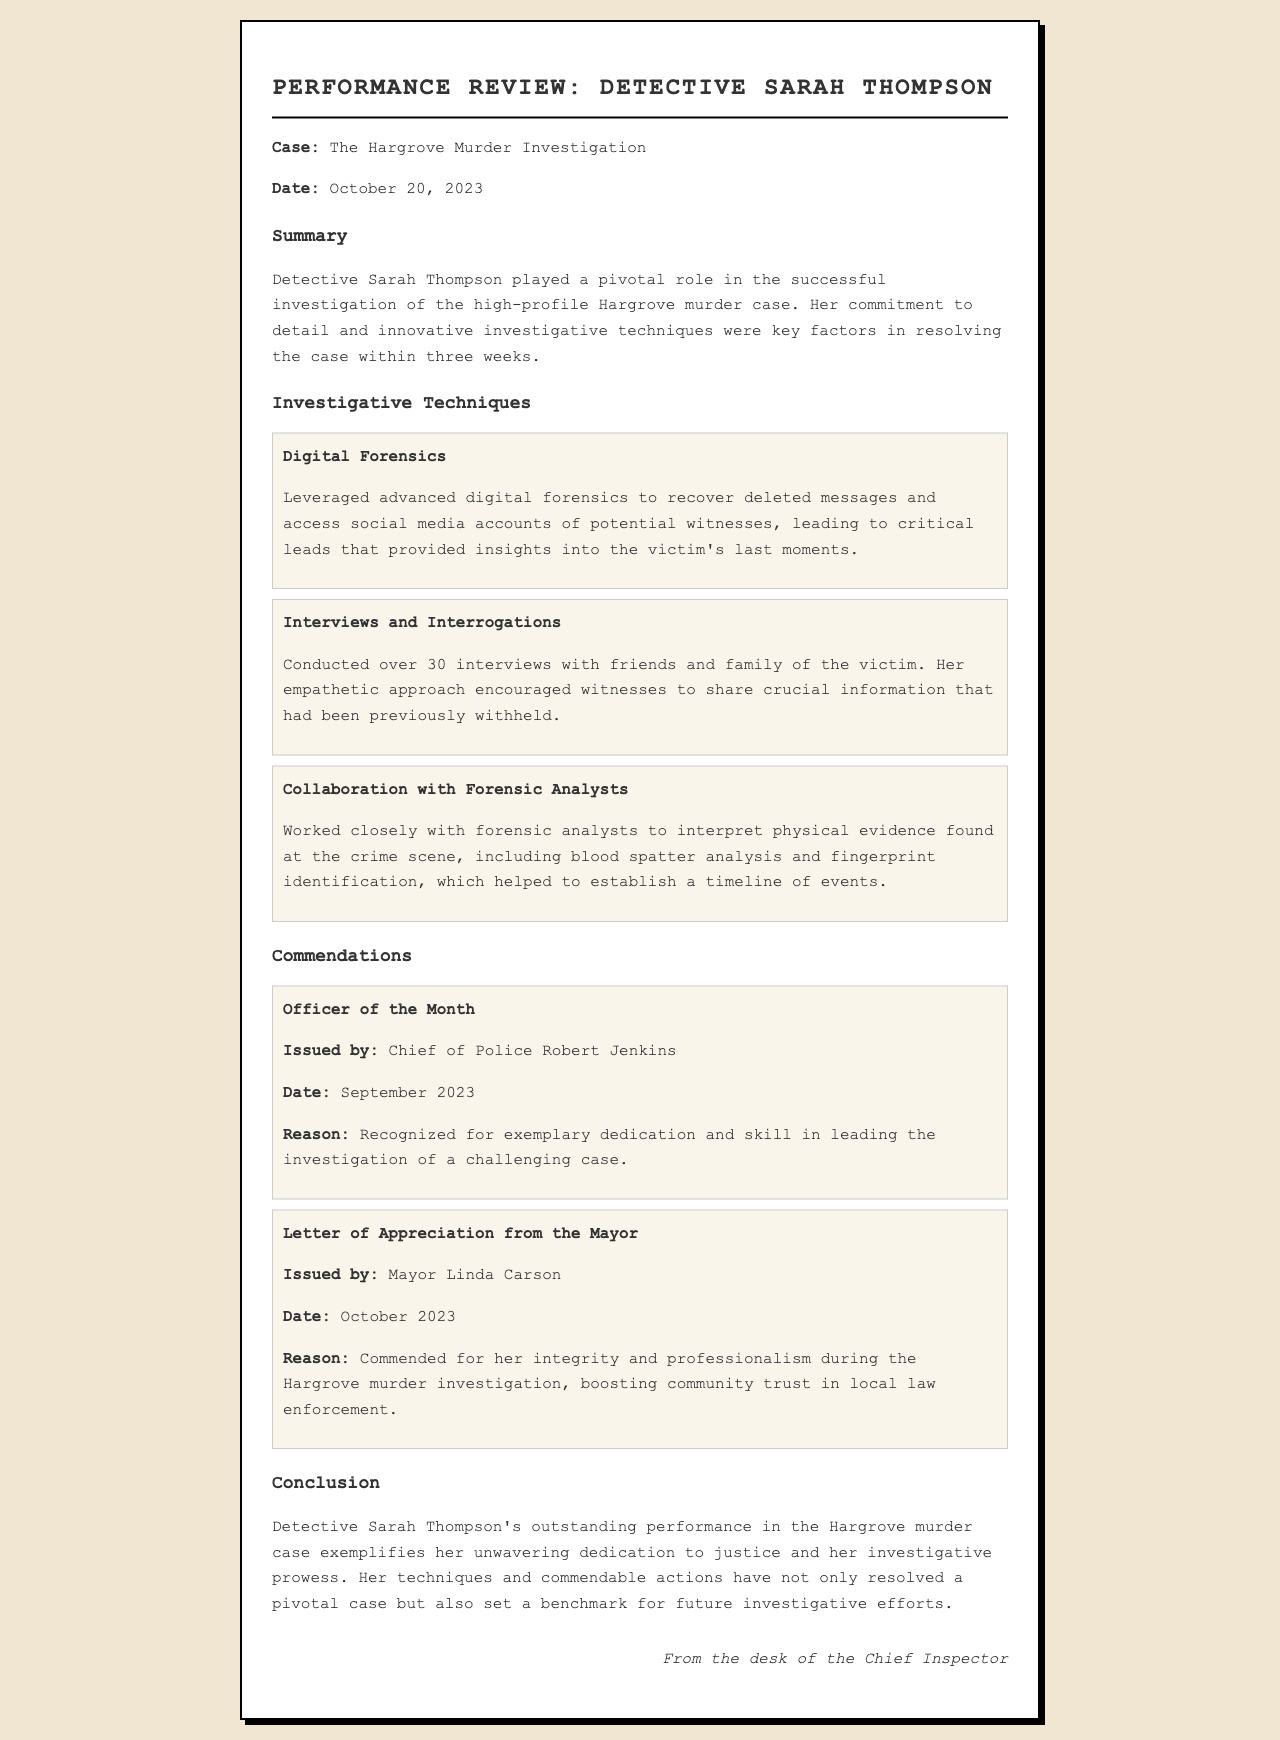What is the name of the detective? The document mentions Detective Sarah Thompson as the main subject of the performance review.
Answer: Sarah Thompson What was the date of the performance review? The review is dated October 20, 2023, as stated at the top of the document.
Answer: October 20, 2023 How many interviews did Detective Thompson conduct? The document specifies that she conducted over 30 interviews during the investigation.
Answer: Over 30 Who issued the Officer of the Month commendation? The commendation was issued by Chief of Police Robert Jenkins, as noted in the commendation section.
Answer: Chief of Police Robert Jenkins What innovative technique did Detective Thompson use related to digital evidence? The review highlights her use of advanced digital forensics to recover deleted messages and access social media accounts.
Answer: Advanced digital forensics What was the reason for the Mayor's letter of appreciation? The letter commended her integrity and professionalism during the investigation, boosting community trust.
Answer: Integrity and professionalism What case was Detective Thompson involved in? The performance review focuses on her role in the Hargrove murder investigation.
Answer: The Hargrove murder investigation What crime scene evidence did she collaborate with forensic analysts to interpret? She worked with analysts on blood spatter analysis and fingerprint identification as mentioned in the investigative techniques section.
Answer: Blood spatter analysis and fingerprint identification 